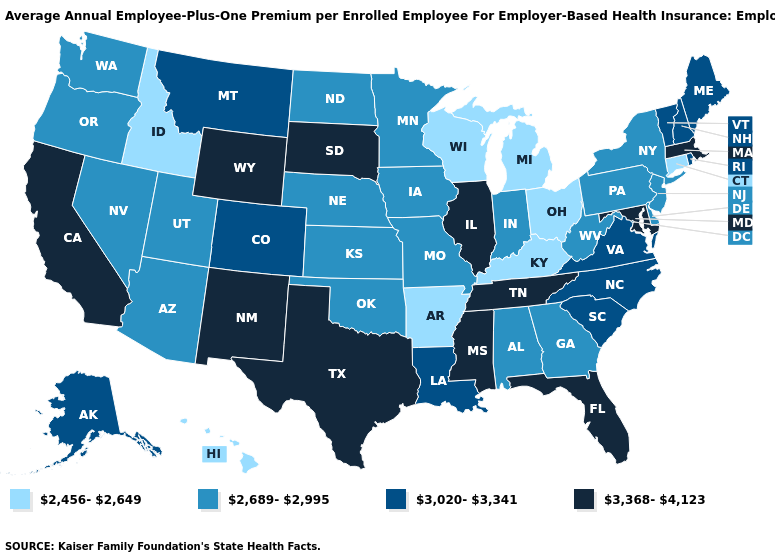Among the states that border Indiana , which have the lowest value?
Give a very brief answer. Kentucky, Michigan, Ohio. Among the states that border Arizona , which have the lowest value?
Answer briefly. Nevada, Utah. Name the states that have a value in the range 2,689-2,995?
Answer briefly. Alabama, Arizona, Delaware, Georgia, Indiana, Iowa, Kansas, Minnesota, Missouri, Nebraska, Nevada, New Jersey, New York, North Dakota, Oklahoma, Oregon, Pennsylvania, Utah, Washington, West Virginia. What is the lowest value in the USA?
Give a very brief answer. 2,456-2,649. How many symbols are there in the legend?
Quick response, please. 4. Does the first symbol in the legend represent the smallest category?
Concise answer only. Yes. Which states have the lowest value in the USA?
Concise answer only. Arkansas, Connecticut, Hawaii, Idaho, Kentucky, Michigan, Ohio, Wisconsin. Name the states that have a value in the range 3,020-3,341?
Give a very brief answer. Alaska, Colorado, Louisiana, Maine, Montana, New Hampshire, North Carolina, Rhode Island, South Carolina, Vermont, Virginia. Does Hawaii have a lower value than Nevada?
Short answer required. Yes. What is the highest value in the South ?
Write a very short answer. 3,368-4,123. Which states have the lowest value in the MidWest?
Keep it brief. Michigan, Ohio, Wisconsin. What is the value of Michigan?
Be succinct. 2,456-2,649. What is the highest value in the USA?
Be succinct. 3,368-4,123. What is the value of Alabama?
Short answer required. 2,689-2,995. What is the lowest value in the USA?
Write a very short answer. 2,456-2,649. 